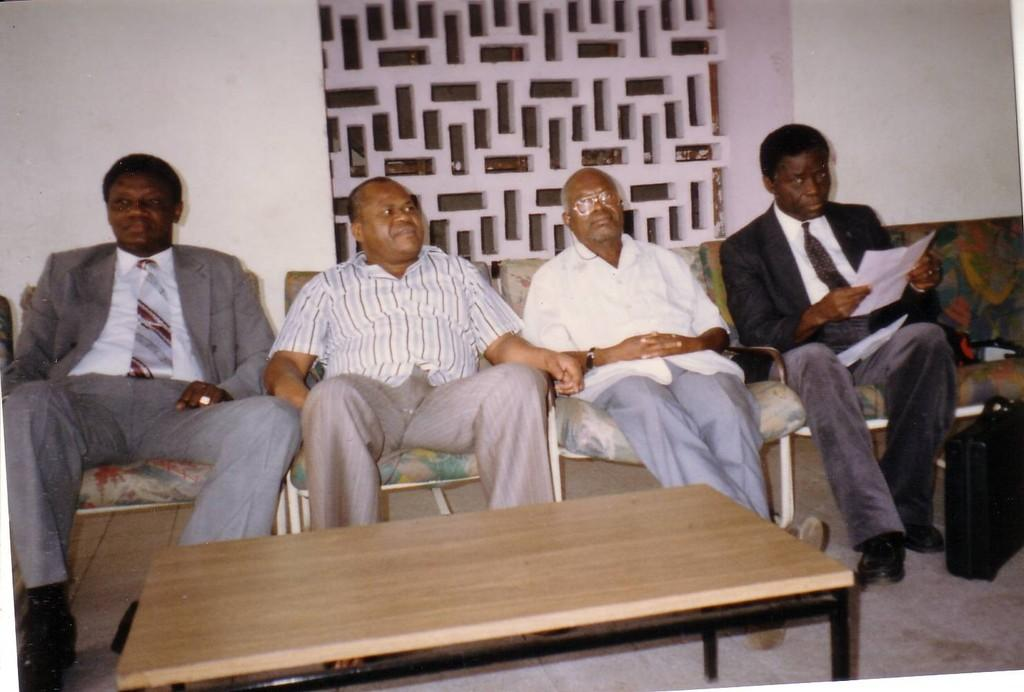How many people are in the image? There are four persons in the image. What are the persons doing in the image? The persons are sitting in chairs. What is in front of the persons? There is a table in front of the persons. What color is the background wall in the image? The background wall is white in color. Can you see any cherries on the table in the image? There is no mention of cherries in the image, so we cannot determine if they are present or not. How many feet are visible in the image? The image does not show the persons' feet, so we cannot determine the number of feet visible. 